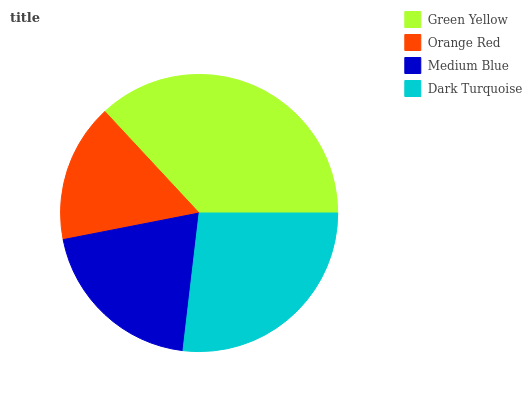Is Orange Red the minimum?
Answer yes or no. Yes. Is Green Yellow the maximum?
Answer yes or no. Yes. Is Medium Blue the minimum?
Answer yes or no. No. Is Medium Blue the maximum?
Answer yes or no. No. Is Medium Blue greater than Orange Red?
Answer yes or no. Yes. Is Orange Red less than Medium Blue?
Answer yes or no. Yes. Is Orange Red greater than Medium Blue?
Answer yes or no. No. Is Medium Blue less than Orange Red?
Answer yes or no. No. Is Dark Turquoise the high median?
Answer yes or no. Yes. Is Medium Blue the low median?
Answer yes or no. Yes. Is Orange Red the high median?
Answer yes or no. No. Is Green Yellow the low median?
Answer yes or no. No. 